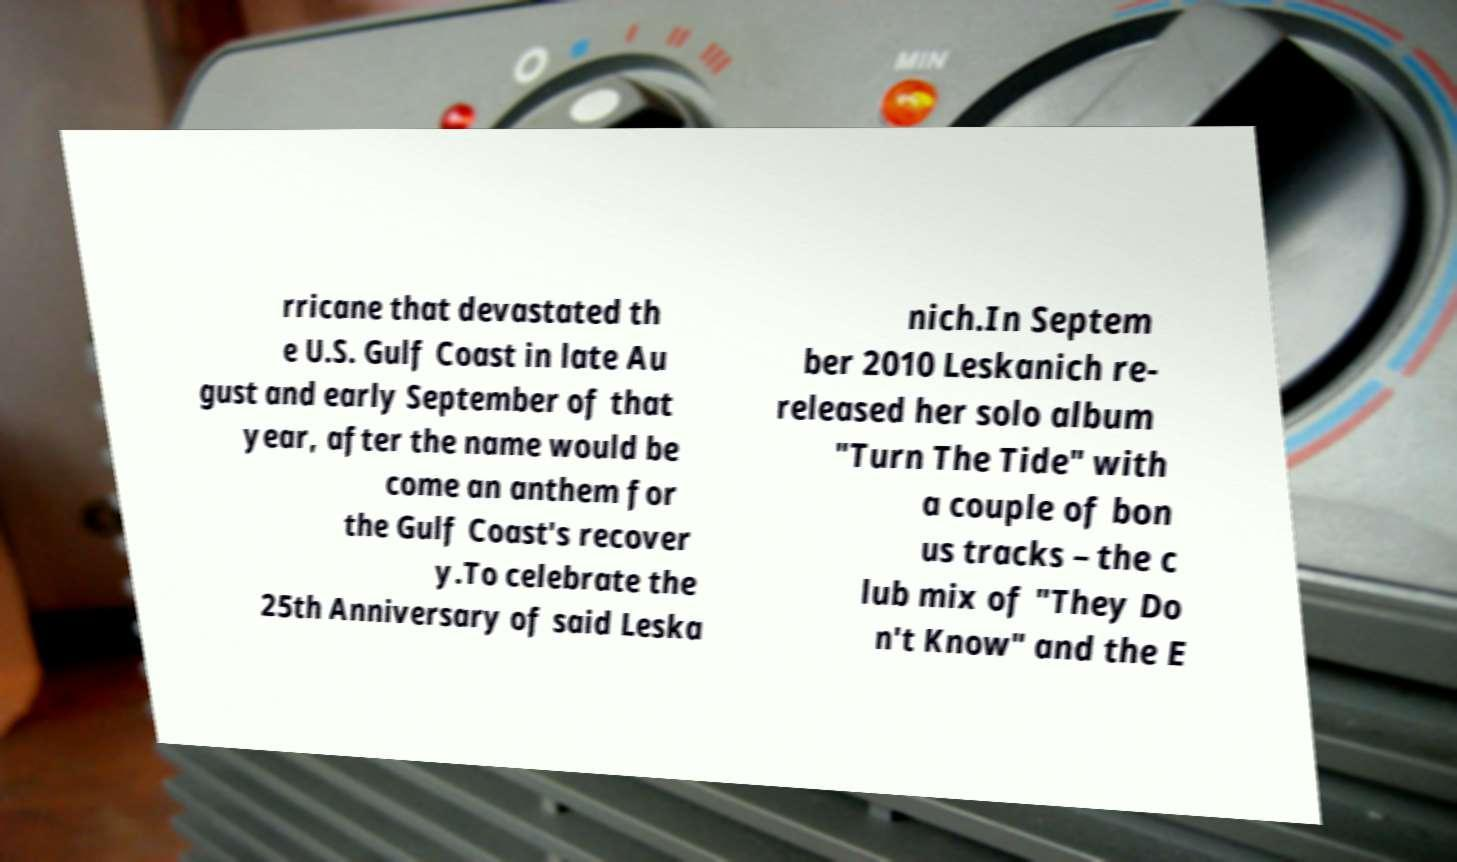Please identify and transcribe the text found in this image. rricane that devastated th e U.S. Gulf Coast in late Au gust and early September of that year, after the name would be come an anthem for the Gulf Coast's recover y.To celebrate the 25th Anniversary of said Leska nich.In Septem ber 2010 Leskanich re- released her solo album "Turn The Tide" with a couple of bon us tracks – the c lub mix of "They Do n't Know" and the E 